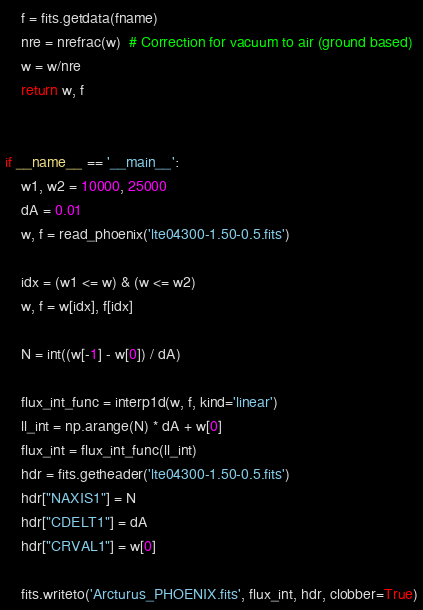<code> <loc_0><loc_0><loc_500><loc_500><_Python_>    f = fits.getdata(fname)
    nre = nrefrac(w)  # Correction for vacuum to air (ground based)
    w = w/nre
    return w, f


if __name__ == '__main__':
    w1, w2 = 10000, 25000
    dA = 0.01
    w, f = read_phoenix('lte04300-1.50-0.5.fits')

    idx = (w1 <= w) & (w <= w2)
    w, f = w[idx], f[idx]

    N = int((w[-1] - w[0]) / dA)

    flux_int_func = interp1d(w, f, kind='linear')
    ll_int = np.arange(N) * dA + w[0]
    flux_int = flux_int_func(ll_int)
    hdr = fits.getheader('lte04300-1.50-0.5.fits')
    hdr["NAXIS1"] = N
    hdr["CDELT1"] = dA
    hdr["CRVAL1"] = w[0]

    fits.writeto('Arcturus_PHOENIX.fits', flux_int, hdr, clobber=True)
</code> 